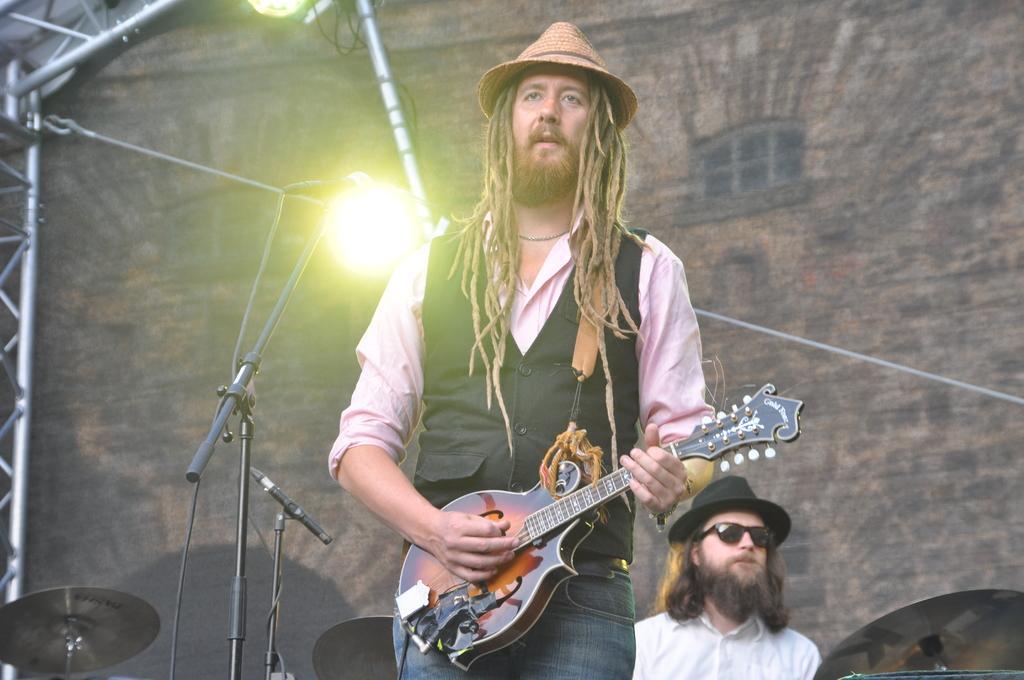Please provide a concise description of this image. The man in black jacket is playing a guitar in-front of mic. This is a focusing light attached to a rod. This person in white shirt wore goggles and hat. 